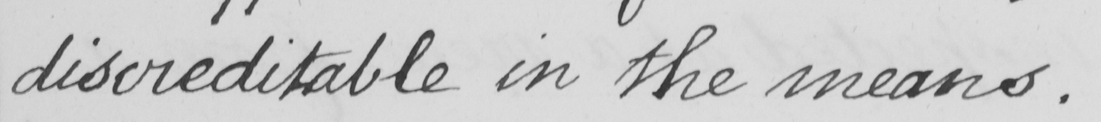Please provide the text content of this handwritten line. discreditable in the means . 